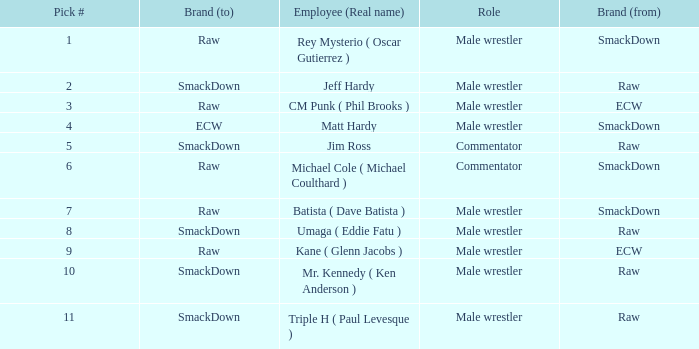What is the real name of the Pick # that is greater than 9? Mr. Kennedy ( Ken Anderson ), Triple H ( Paul Levesque ). 